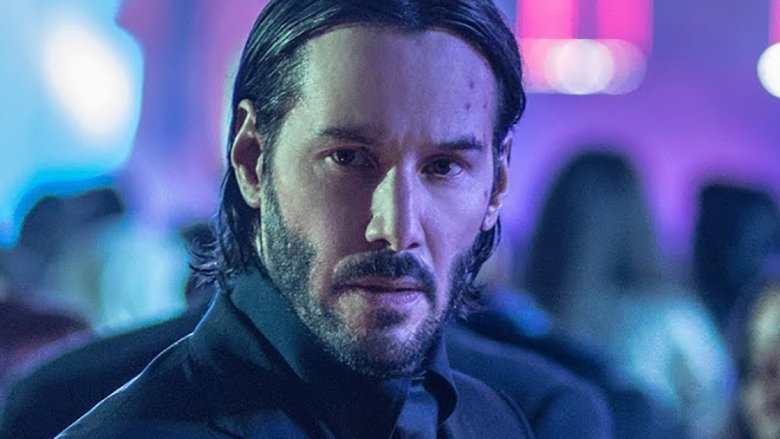Describe the ambiance of the setting shown in the image. The setting in the image is vibrant and lively, characterized by a nightclub atmosphere with an array of colorful lights. These lights cast a kaleidoscopic glow that fills the space, adding a sense of excitement and energy. The blurred movement of people in the background suggests the club is crowded and bustling, creating a stark contrast with the calm demeanor of the man in the foreground. 